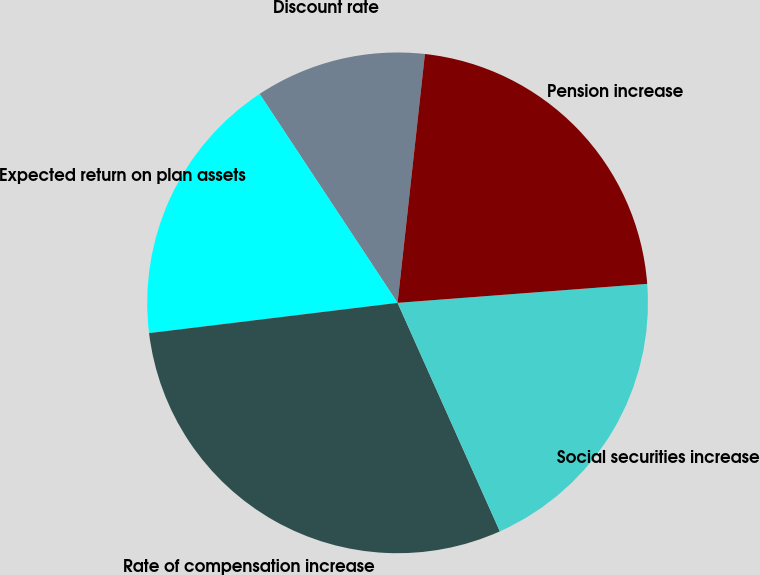<chart> <loc_0><loc_0><loc_500><loc_500><pie_chart><fcel>Discount rate<fcel>Expected return on plan assets<fcel>Rate of compensation increase<fcel>Social securities increase<fcel>Pension increase<nl><fcel>11.03%<fcel>17.64%<fcel>29.77%<fcel>19.51%<fcel>22.05%<nl></chart> 